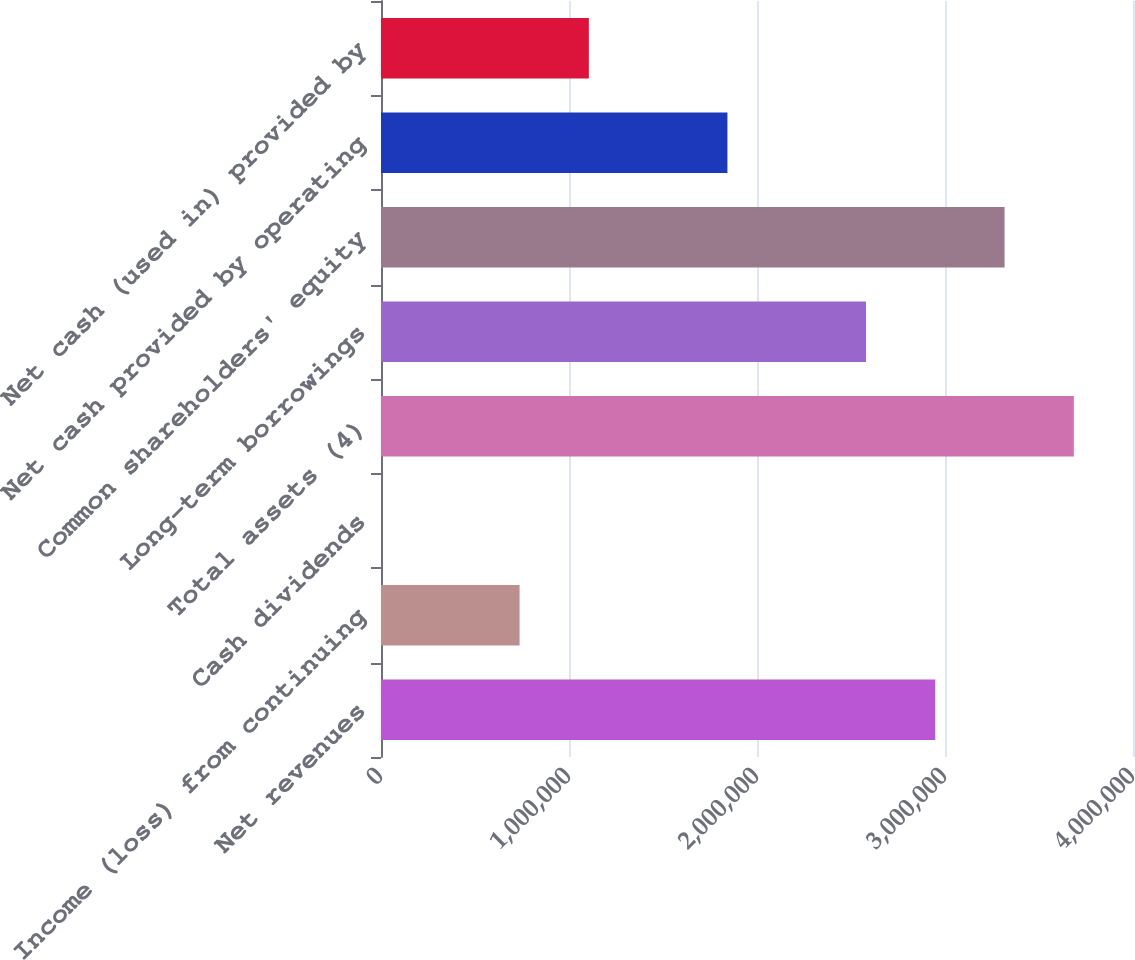<chart> <loc_0><loc_0><loc_500><loc_500><bar_chart><fcel>Net revenues<fcel>Income (loss) from continuing<fcel>Cash dividends<fcel>Total assets (4)<fcel>Long-term borrowings<fcel>Common shareholders' equity<fcel>Net cash provided by operating<fcel>Net cash (used in) provided by<nl><fcel>2.94835e+06<fcel>737089<fcel>1.36<fcel>3.68544e+06<fcel>2.57981e+06<fcel>3.31689e+06<fcel>1.84272e+06<fcel>1.10563e+06<nl></chart> 